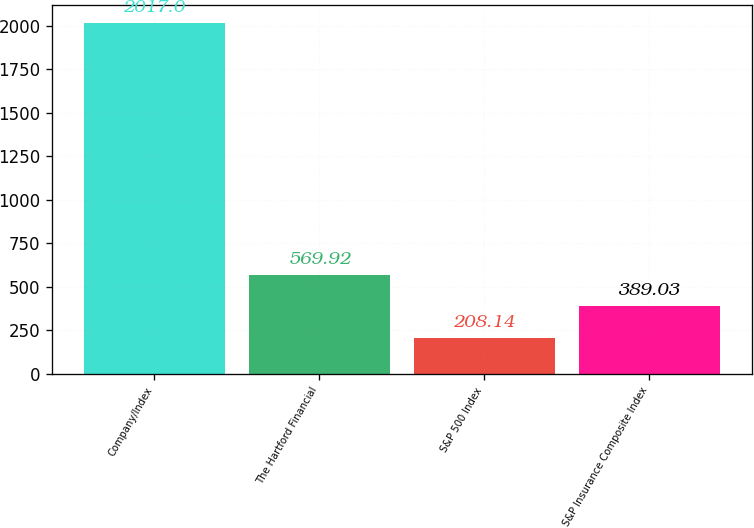<chart> <loc_0><loc_0><loc_500><loc_500><bar_chart><fcel>Company/Index<fcel>The Hartford Financial<fcel>S&P 500 Index<fcel>S&P Insurance Composite Index<nl><fcel>2017<fcel>569.92<fcel>208.14<fcel>389.03<nl></chart> 